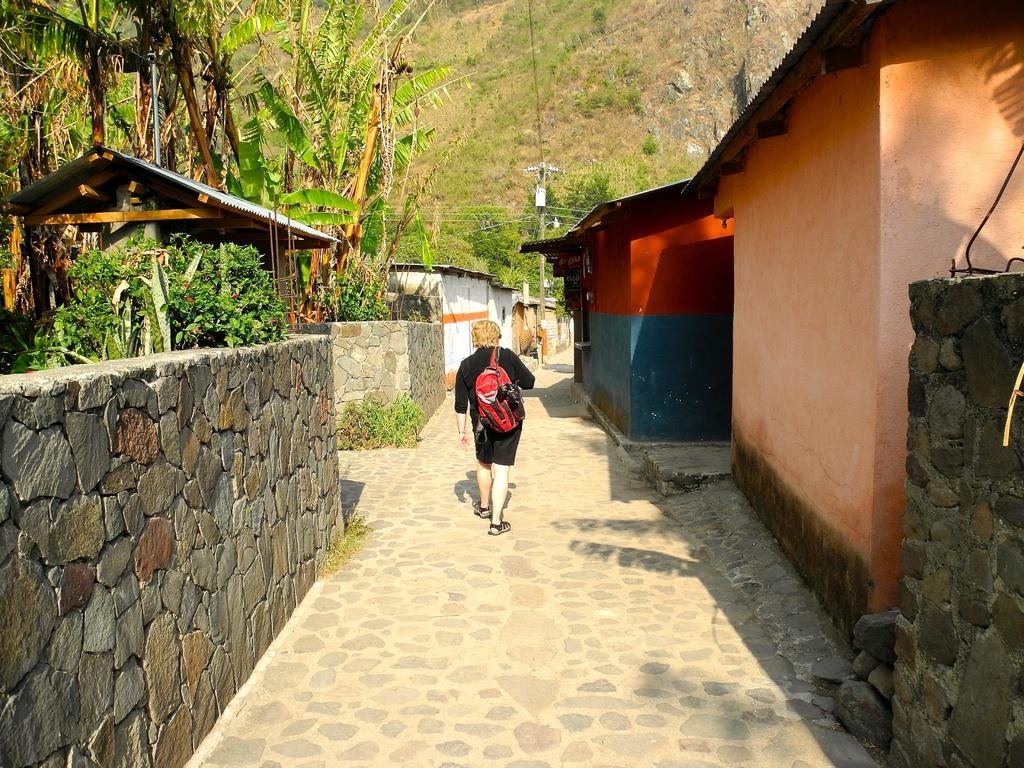What is the person in the image doing? There is a person walking on the road in the image. What type of structures can be seen in the image? There are houses in the image. What is the purpose of the wall in the image? The wall in the image serves as a boundary or barrier. What type of vegetation is present in the image? There are plants and trees in the image. What are the poles used for in the image? The poles in the image may be used for supporting wires or other infrastructure. Can you tell me how many chess pieces are on the table in the image? There is no table or chess pieces present in the image. What advice does the parent give to the child in the image? There is no parent or child present in the image. 